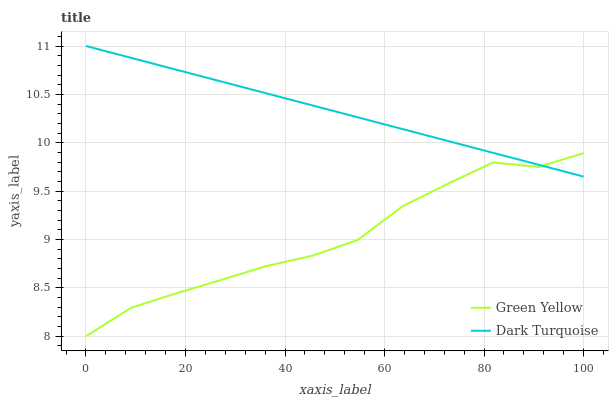Does Green Yellow have the minimum area under the curve?
Answer yes or no. Yes. Does Dark Turquoise have the maximum area under the curve?
Answer yes or no. Yes. Does Green Yellow have the maximum area under the curve?
Answer yes or no. No. Is Dark Turquoise the smoothest?
Answer yes or no. Yes. Is Green Yellow the roughest?
Answer yes or no. Yes. Is Green Yellow the smoothest?
Answer yes or no. No. Does Green Yellow have the lowest value?
Answer yes or no. Yes. Does Dark Turquoise have the highest value?
Answer yes or no. Yes. Does Green Yellow have the highest value?
Answer yes or no. No. Does Dark Turquoise intersect Green Yellow?
Answer yes or no. Yes. Is Dark Turquoise less than Green Yellow?
Answer yes or no. No. Is Dark Turquoise greater than Green Yellow?
Answer yes or no. No. 